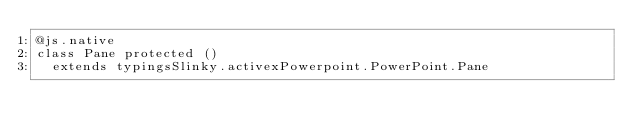<code> <loc_0><loc_0><loc_500><loc_500><_Scala_>@js.native
class Pane protected ()
  extends typingsSlinky.activexPowerpoint.PowerPoint.Pane
</code> 